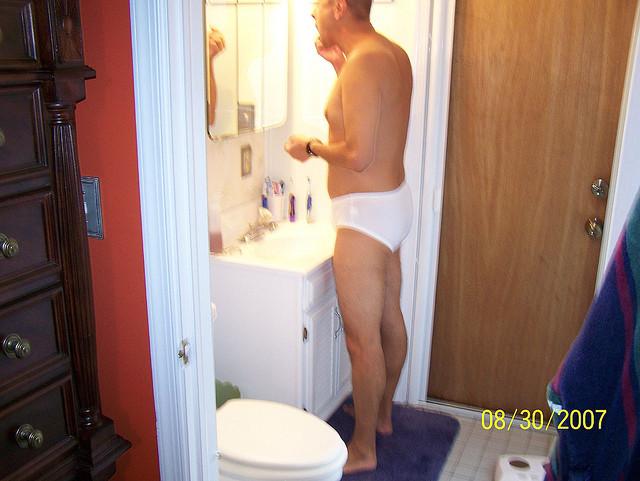What is the man wearing?
Keep it brief. Underwear. Does this man have skid marks?
Be succinct. No. What room is this?
Write a very short answer. Bathroom. What is the man holding in his hands?
Short answer required. Floss. 